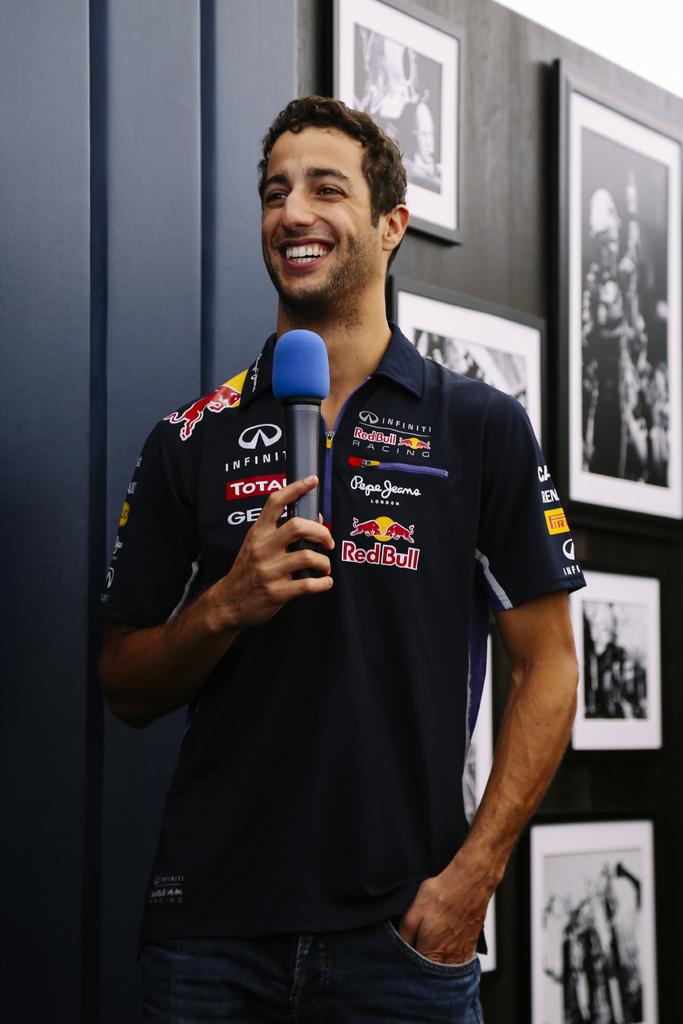What car company is sponsoring this person?
Provide a short and direct response. Infiniti. Which energy drink is on the shirt?
Your answer should be very brief. Red bull. 